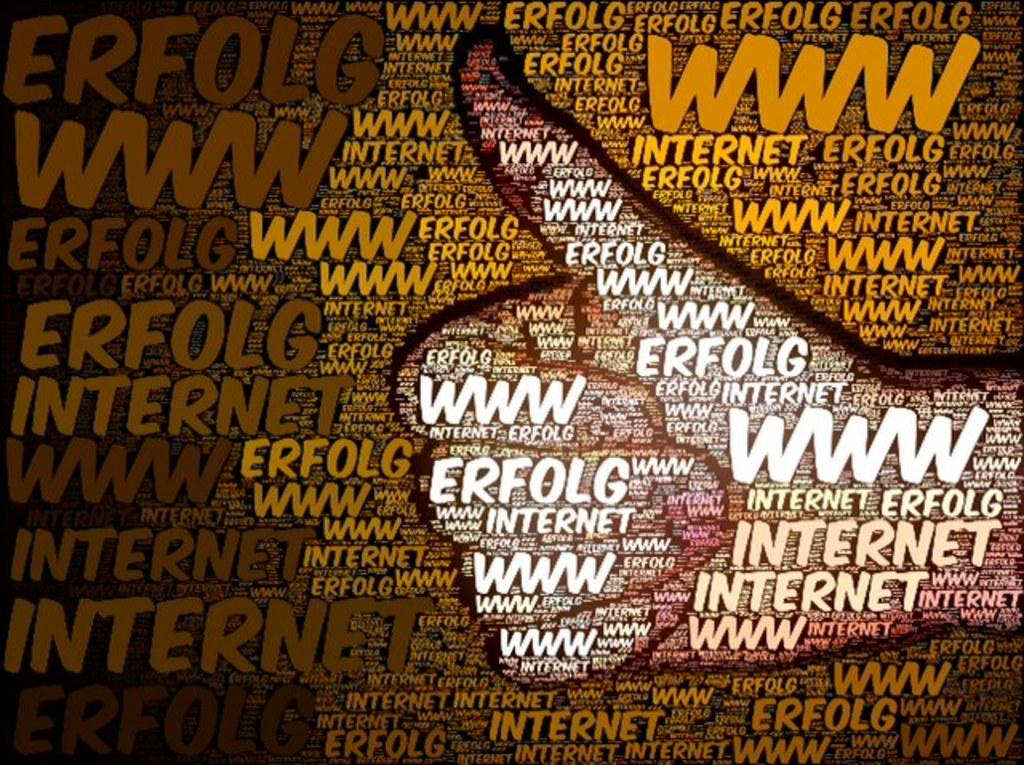<image>
Summarize the visual content of the image. A picture with the word internet written all over it and a hand giving the thumbs up sign superimposed on top. 